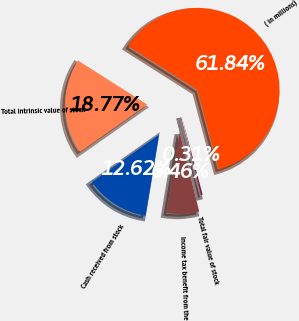Convert chart. <chart><loc_0><loc_0><loc_500><loc_500><pie_chart><fcel>( in millions)<fcel>Total intrinsic value of stock<fcel>Cash received from stock<fcel>Income tax benefit from the<fcel>Total fair value of stock<nl><fcel>61.85%<fcel>18.77%<fcel>12.62%<fcel>6.46%<fcel>0.31%<nl></chart> 